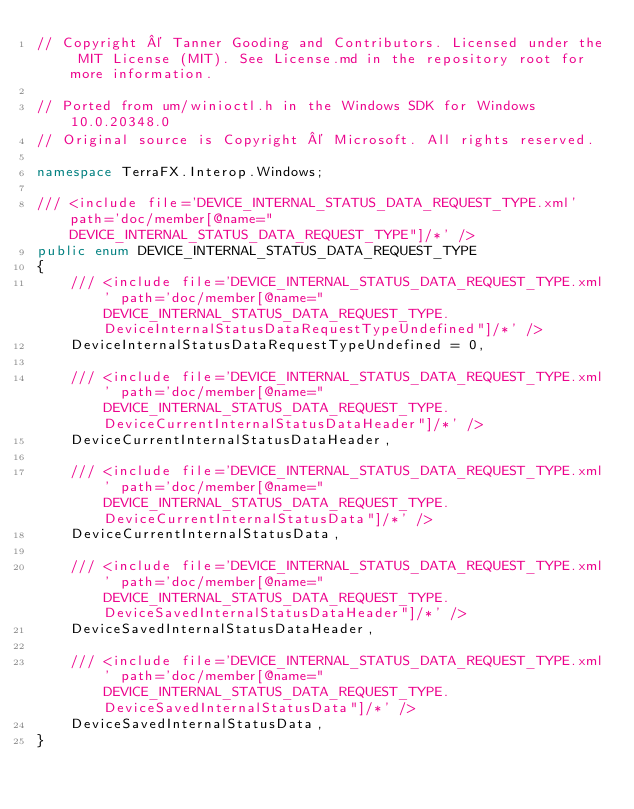Convert code to text. <code><loc_0><loc_0><loc_500><loc_500><_C#_>// Copyright © Tanner Gooding and Contributors. Licensed under the MIT License (MIT). See License.md in the repository root for more information.

// Ported from um/winioctl.h in the Windows SDK for Windows 10.0.20348.0
// Original source is Copyright © Microsoft. All rights reserved.

namespace TerraFX.Interop.Windows;

/// <include file='DEVICE_INTERNAL_STATUS_DATA_REQUEST_TYPE.xml' path='doc/member[@name="DEVICE_INTERNAL_STATUS_DATA_REQUEST_TYPE"]/*' />
public enum DEVICE_INTERNAL_STATUS_DATA_REQUEST_TYPE
{
    /// <include file='DEVICE_INTERNAL_STATUS_DATA_REQUEST_TYPE.xml' path='doc/member[@name="DEVICE_INTERNAL_STATUS_DATA_REQUEST_TYPE.DeviceInternalStatusDataRequestTypeUndefined"]/*' />
    DeviceInternalStatusDataRequestTypeUndefined = 0,

    /// <include file='DEVICE_INTERNAL_STATUS_DATA_REQUEST_TYPE.xml' path='doc/member[@name="DEVICE_INTERNAL_STATUS_DATA_REQUEST_TYPE.DeviceCurrentInternalStatusDataHeader"]/*' />
    DeviceCurrentInternalStatusDataHeader,

    /// <include file='DEVICE_INTERNAL_STATUS_DATA_REQUEST_TYPE.xml' path='doc/member[@name="DEVICE_INTERNAL_STATUS_DATA_REQUEST_TYPE.DeviceCurrentInternalStatusData"]/*' />
    DeviceCurrentInternalStatusData,

    /// <include file='DEVICE_INTERNAL_STATUS_DATA_REQUEST_TYPE.xml' path='doc/member[@name="DEVICE_INTERNAL_STATUS_DATA_REQUEST_TYPE.DeviceSavedInternalStatusDataHeader"]/*' />
    DeviceSavedInternalStatusDataHeader,

    /// <include file='DEVICE_INTERNAL_STATUS_DATA_REQUEST_TYPE.xml' path='doc/member[@name="DEVICE_INTERNAL_STATUS_DATA_REQUEST_TYPE.DeviceSavedInternalStatusData"]/*' />
    DeviceSavedInternalStatusData,
}
</code> 